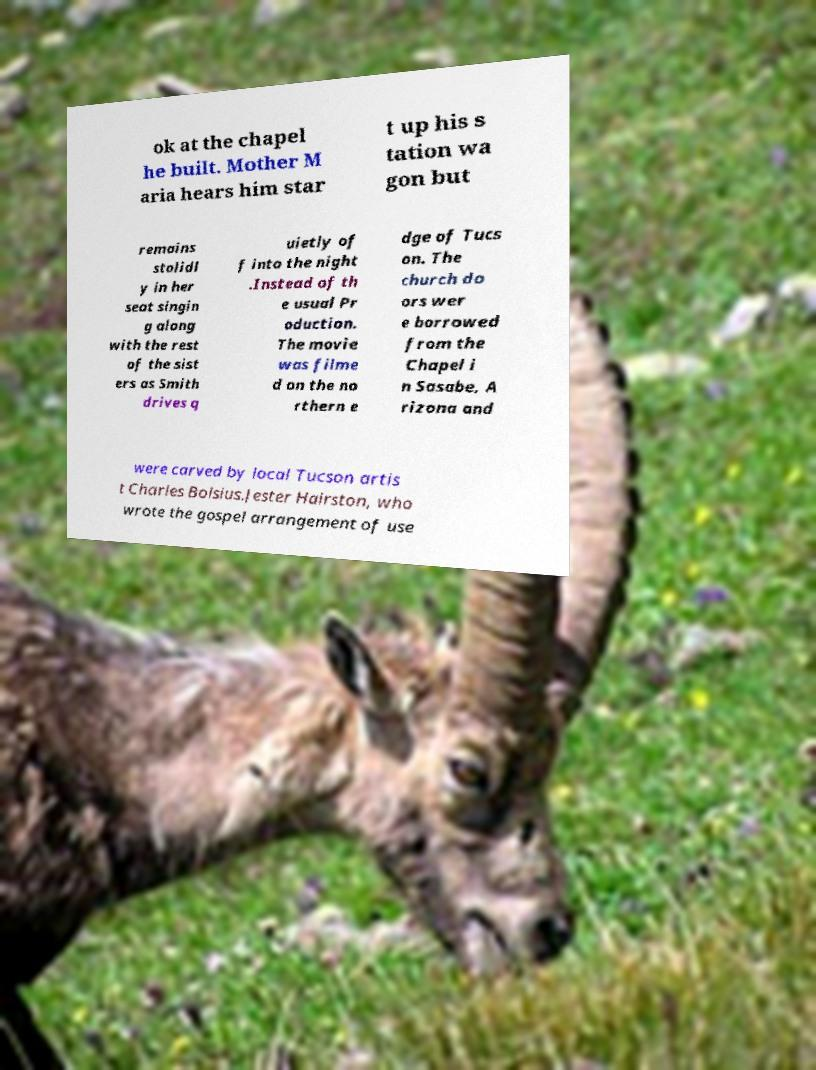For documentation purposes, I need the text within this image transcribed. Could you provide that? ok at the chapel he built. Mother M aria hears him star t up his s tation wa gon but remains stolidl y in her seat singin g along with the rest of the sist ers as Smith drives q uietly of f into the night .Instead of th e usual Pr oduction. The movie was filme d on the no rthern e dge of Tucs on. The church do ors wer e borrowed from the Chapel i n Sasabe, A rizona and were carved by local Tucson artis t Charles Bolsius.Jester Hairston, who wrote the gospel arrangement of use 